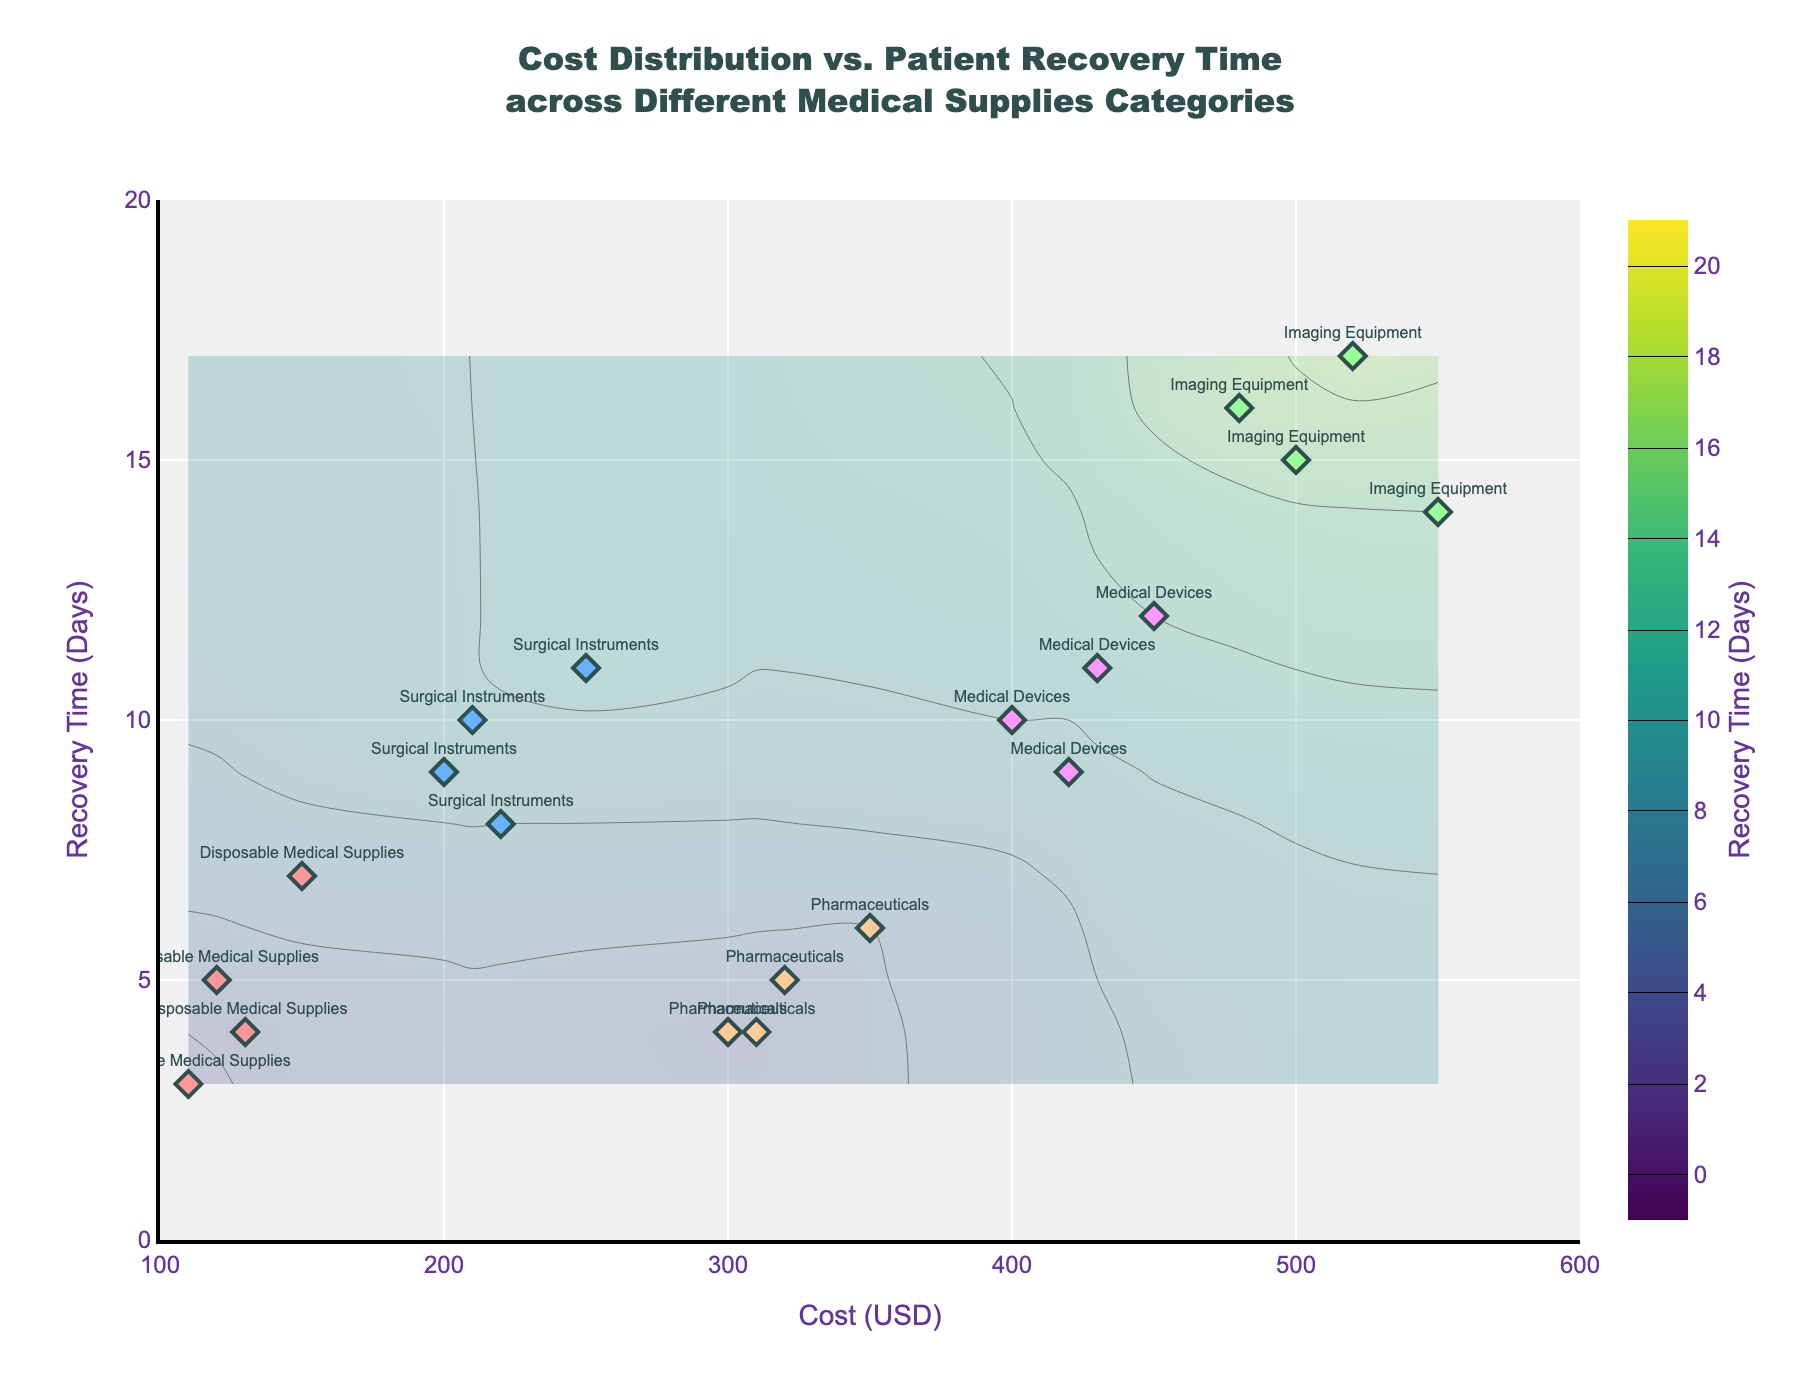What's the title of the plot? The title of the plot is presented at the top center of the figure. It reads: "Cost Distribution vs. Patient Recovery Time across Different Medical Supplies Categories".
Answer: Cost Distribution vs. Patient Recovery Time across Different Medical Supplies Categories What does the x-axis represent? The x-axis label is given in the figure, which reads "Cost (USD)". This indicates that the x-axis represents the cost of medical supplies in USD.
Answer: Cost (USD) What color represents "Surgical Instruments"? By referring to the color legend or the color of markers labeled as "Surgical Instruments" in the plot, it is clear that "Surgical Instruments" are represented by the light blue color.
Answer: Light blue What's the median Recovery Time for Imaging Equipment? Imaging Equipment has recovery times of 14, 15, 16, and 17 days. The median value is the middle number when they are listed in order. Here, the two middle values (15 and 16) average to 15.5.
Answer: 15.5 days Which category presents the highest cost samples? The cost values are compared across categories. "Imaging Equipment" has cost samples in the range of 480 to 550 USD, which is the highest among all categories.
Answer: Imaging Equipment How many categories are displayed in the plot? The plot shows five distinct categories, each represented with different colors and labels: 'Disposable Medical Supplies', 'Surgical Instruments', 'Imaging Equipment', 'Pharmaceuticals', and 'Medical Devices'.
Answer: 5 Which category has the lowest maximum recovery time? The maximum recovery times for each category are compared. "Pharmaceuticals" has a recovery time range from 4 to 6 days, which is the lowest maximum recovery time among all categories.
Answer: Pharmaceuticals Between "Medical Devices" and "Surgical Instruments", which category has a higher minimum cost? The minimum cost for Medical Devices is 400 USD, and for Surgical Instruments, it is 200 USD. Thus, "Medical Devices" has a higher minimum cost.
Answer: Medical Devices What is the color scale used for the contour plot? The contour plot features a color scale varying from yellow to green, typically known as the "Viridis" colorscale.
Answer: Viridis Which category shows the most variation in recovery times? By observing the range of recovery times for each category, "Imaging Equipment" ranges from 14 to 17 days, showing the most variation compared to other categories.
Answer: Imaging Equipment 